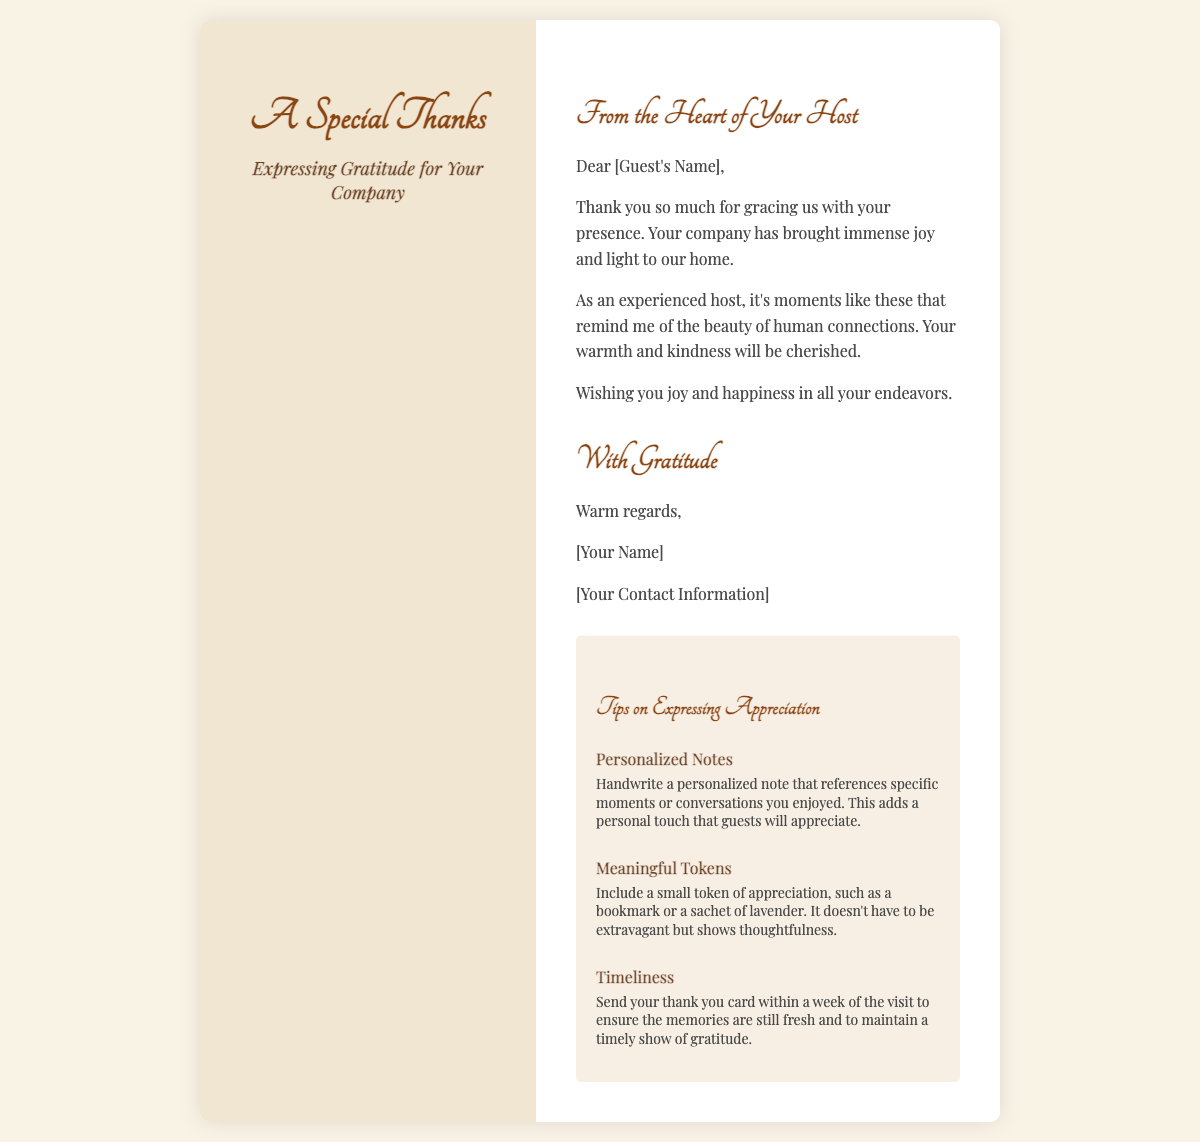What is the title of the card? The title of the card is prominently displayed at the top.
Answer: A Special Thanks Who is the card addressed to? The card includes a placeholder for the recipient's name.
Answer: [Guest's Name] What kind of tone is used in the content? The tone in the content expresses warmth and gratitude.
Answer: Warm What is included as a tip for personalizing notes? One tip suggests adding specific moments from the visit to make the note more personal.
Answer: Handwrite a personalized note How many tips on expressing appreciation are provided? The document lists a total of three tips in the tips section.
Answer: Three What is suggested as a small token of appreciation? The document mentions including a meaningful item that shows thoughtfulness.
Answer: Token of appreciation Who sends the card? The sender of the card is indicated at the bottom below the closing.
Answer: [Your Name] What is the background color of the card? The background color of the card is specified in the style section.
Answer: #f9f3e6 